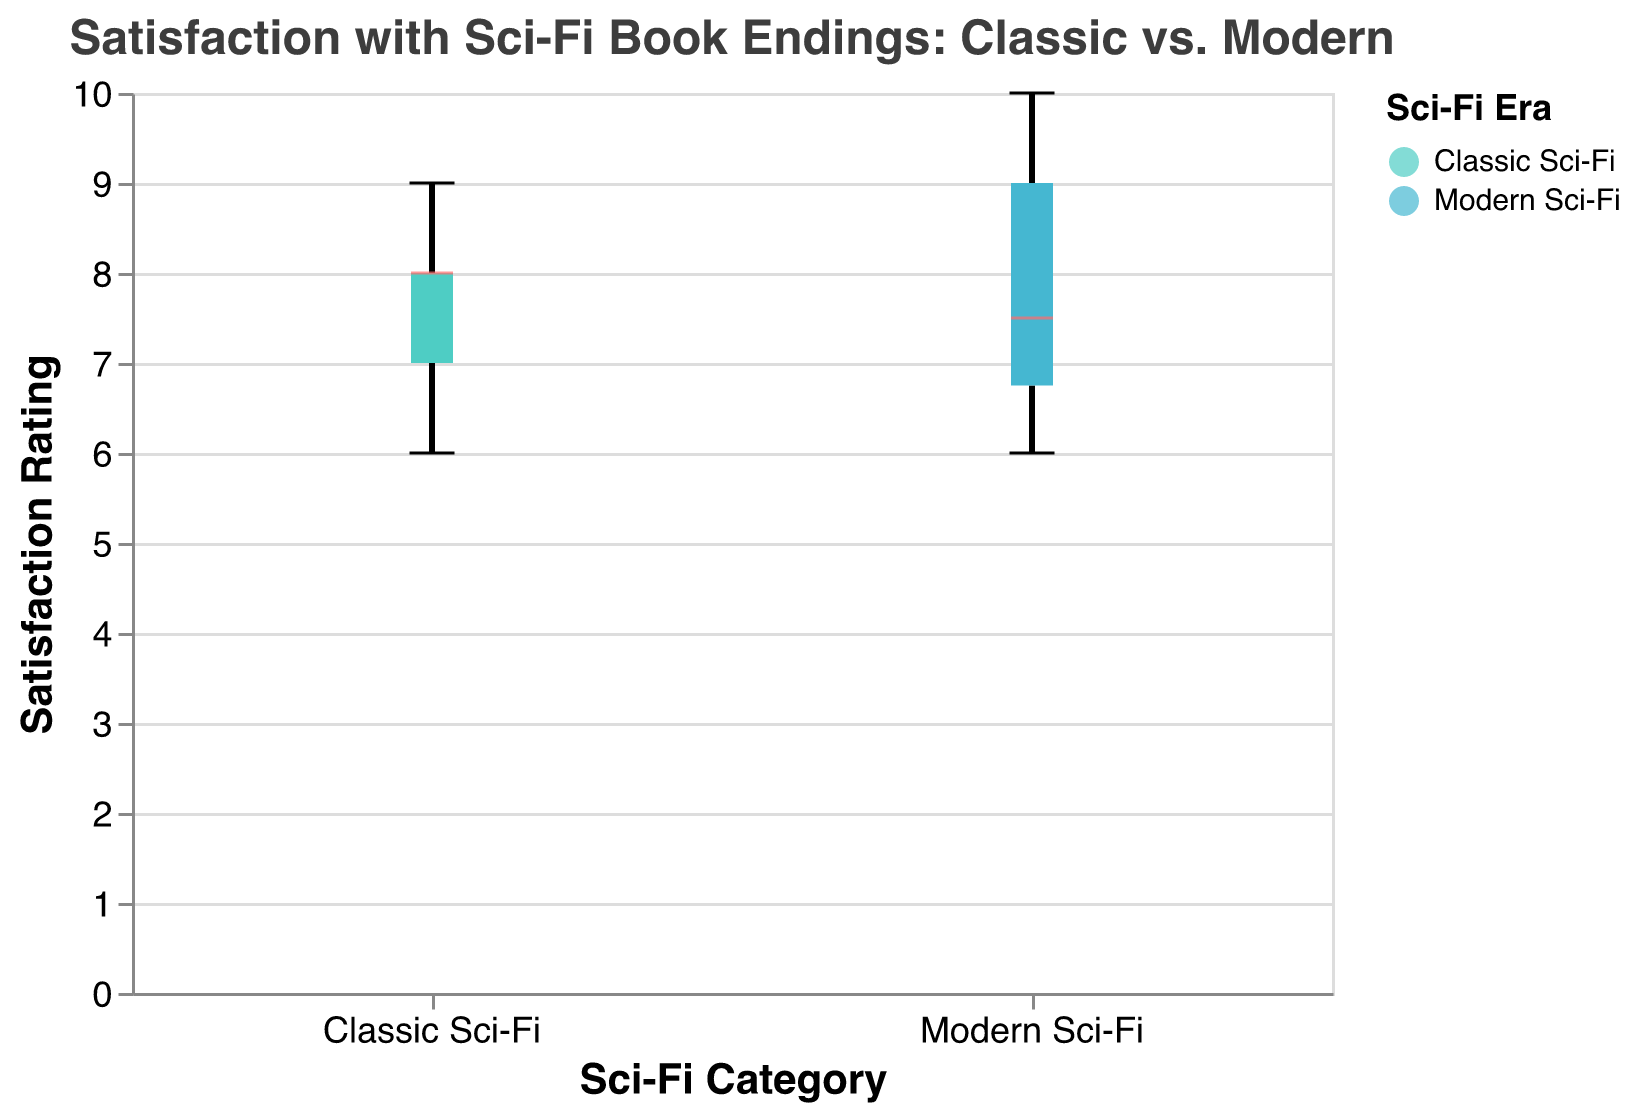What is the title of the figure? The title of the figure is usually found at the top and provides a summary of what the figure represents. Here, it says "Satisfaction with Sci-Fi Book Endings: Classic vs. Modern".
Answer: Satisfaction with Sci-Fi Book Endings: Classic vs. Modern Which category has the highest median satisfaction rating? To determine the highest median satisfaction rating, look at the median lines within each box plot. The color of the median line indicates the value. For Modern Sci-Fi, the median line appears higher on the y-axis compared to Classic Sci-Fi.
Answer: Modern Sci-Fi What is the median satisfaction rating of Modern Sci-Fi book endings? Locate the line within the Modern Sci-Fi box plot that indicates the median value. This line appears to be at the 8 mark on the y-axis.
Answer: 8 Which group has a wider range of satisfaction ratings? The range of satisfaction ratings can be determined by the length of the box plot from the minimum to the maximum values. The Modern Sci-Fi box plot spans from 6 to 10, while the Classic Sci-Fi spans from 6 to 9, indicating Modern Sci-Fi has a wider range.
Answer: Modern Sci-Fi What is the minimum satisfaction rating for both Classic and Modern Sci-Fi? The minimum satisfaction rating is the lowest point on each box plot. In both categories, the value appears at the 6 mark on the y-axis.
Answer: 6 for both Which category has a higher maximum rating, and what is it? The maximum rating is indicated by the topmost point on the box plot. For Modern Sci-Fi, this point reaches 10, whereas Classic Sci-Fi reaches 9.
Answer: Modern Sci-Fi; 10 How do the interquartile ranges (IQRs) compare between the two categories? The IQR is the length of the box in the box plot itself (from the lower quartile to the upper quartile). For Classic Sci-Fi, it ranges approximately from 7 to 8.5, while Modern Sci-Fi ranges from 7 to 9. This shows Modern Sci-Fi has a larger IQR.
Answer: Modern Sci-Fi has a larger IQR What is the third quartile (Q3) for Classic Sci-Fi ratings? The third quartile is the top line of the box in the box plot. For Classic Sci-Fi, Q3 appears to be around the 8.5 mark on the y-axis.
Answer: 8.5 How many data points have a satisfaction rating of 7 in Modern Sci-Fi? Each tick within the box plot represents individual data points. In the Modern Sci-Fi category, two points appear at the rating of 7.
Answer: 2 Is there any outlier present in either of the categories? Outliers in box plots are often represented as individual points outside the whiskers. There are no such points in either category here, indicating no outliers.
Answer: No 